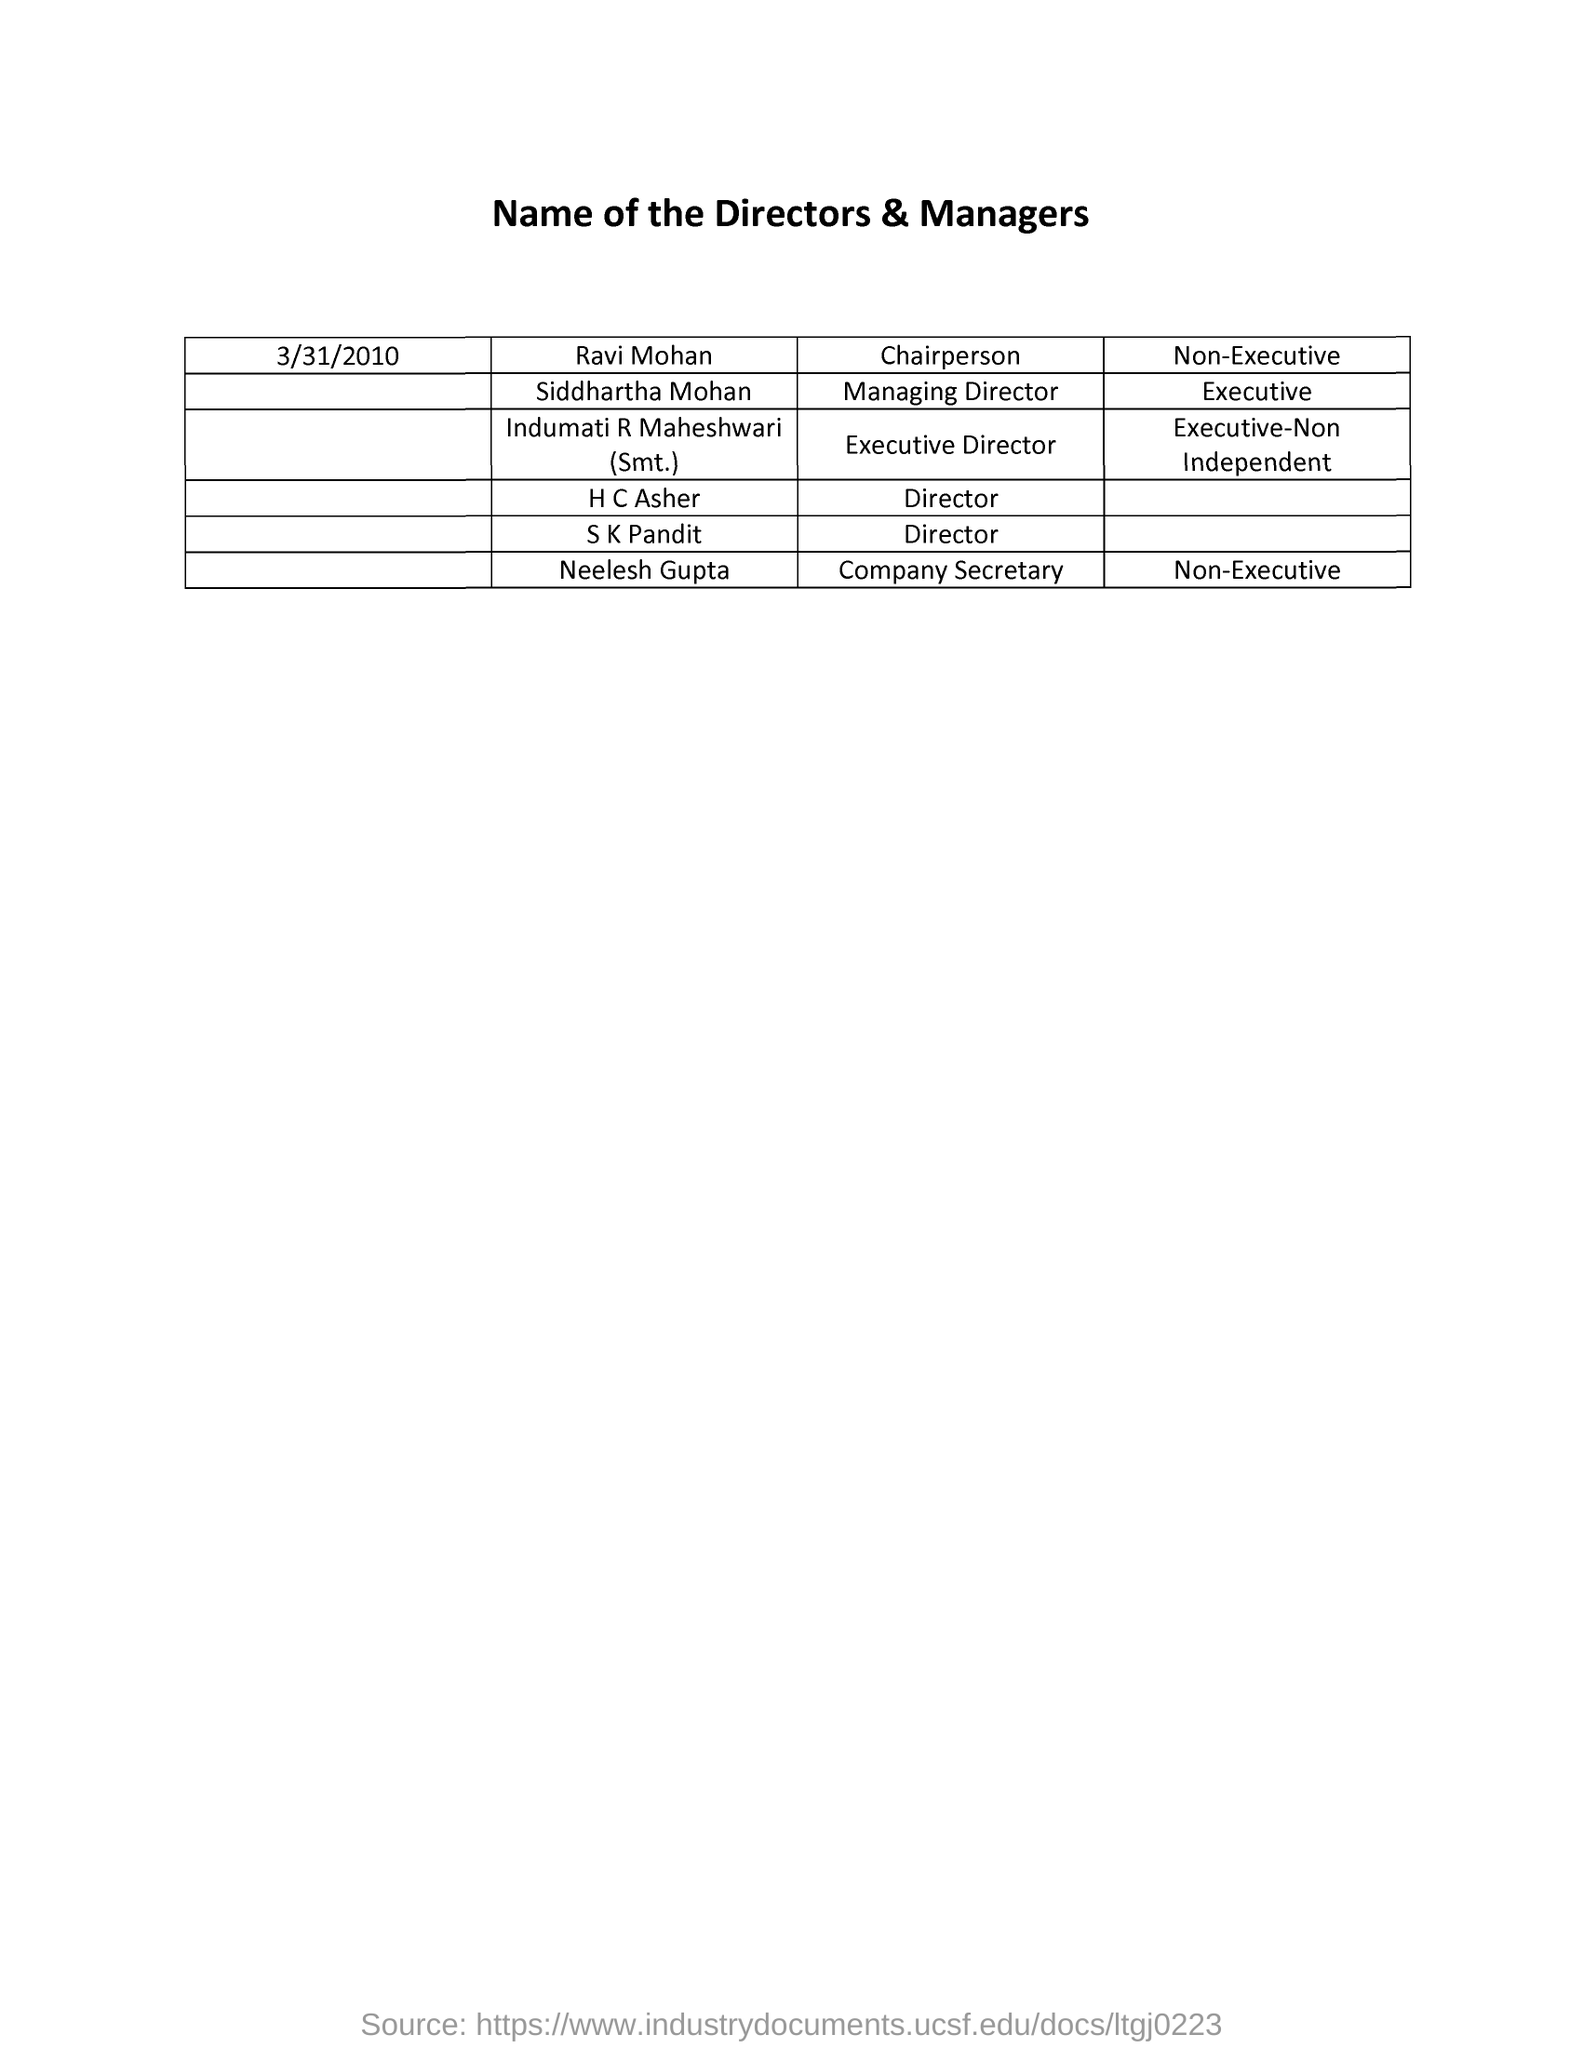What is the Title of the document ?
Offer a very short reply. Name of the Directors & Managers. Who is the Chairperson ?
Provide a short and direct response. Ravi mohan. Who is the Company Secretary ?
Your answer should be compact. Neelesh Gupta. Who is the Managing Director ?
Provide a short and direct response. Siddhartha mohan. When is the Memorandum dated on ?
Keep it short and to the point. 3/31/2010. 